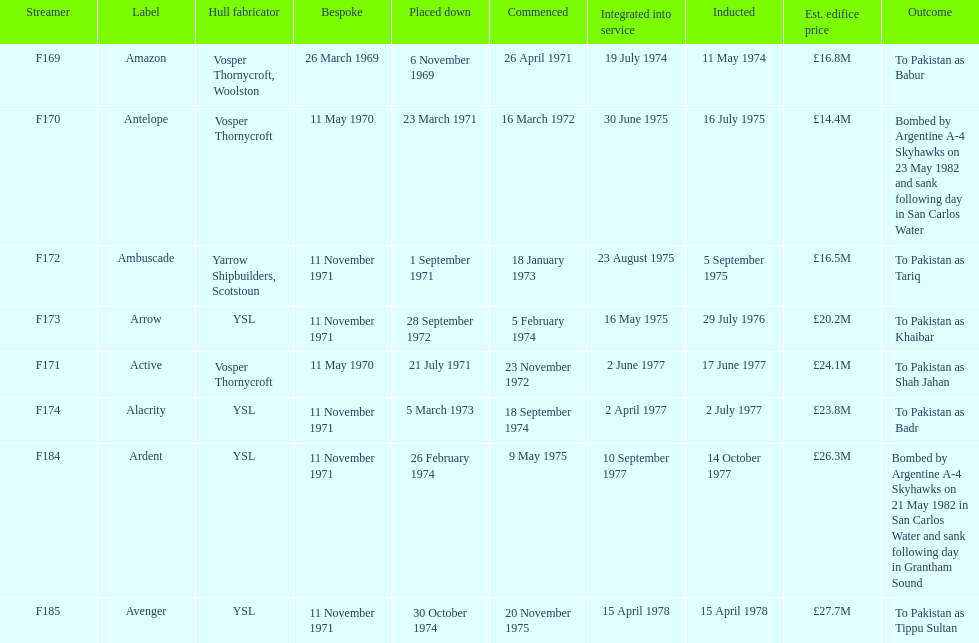Tell me the number of ships that went to pakistan. 6. 